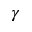<formula> <loc_0><loc_0><loc_500><loc_500>\gamma</formula> 